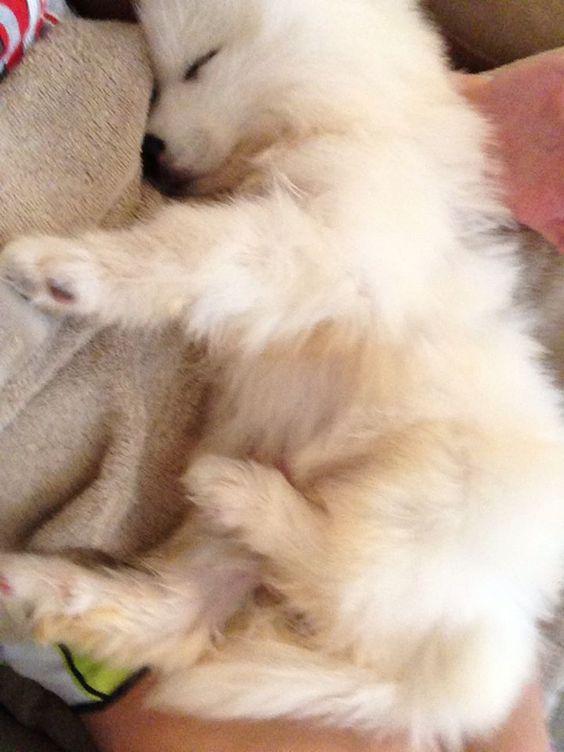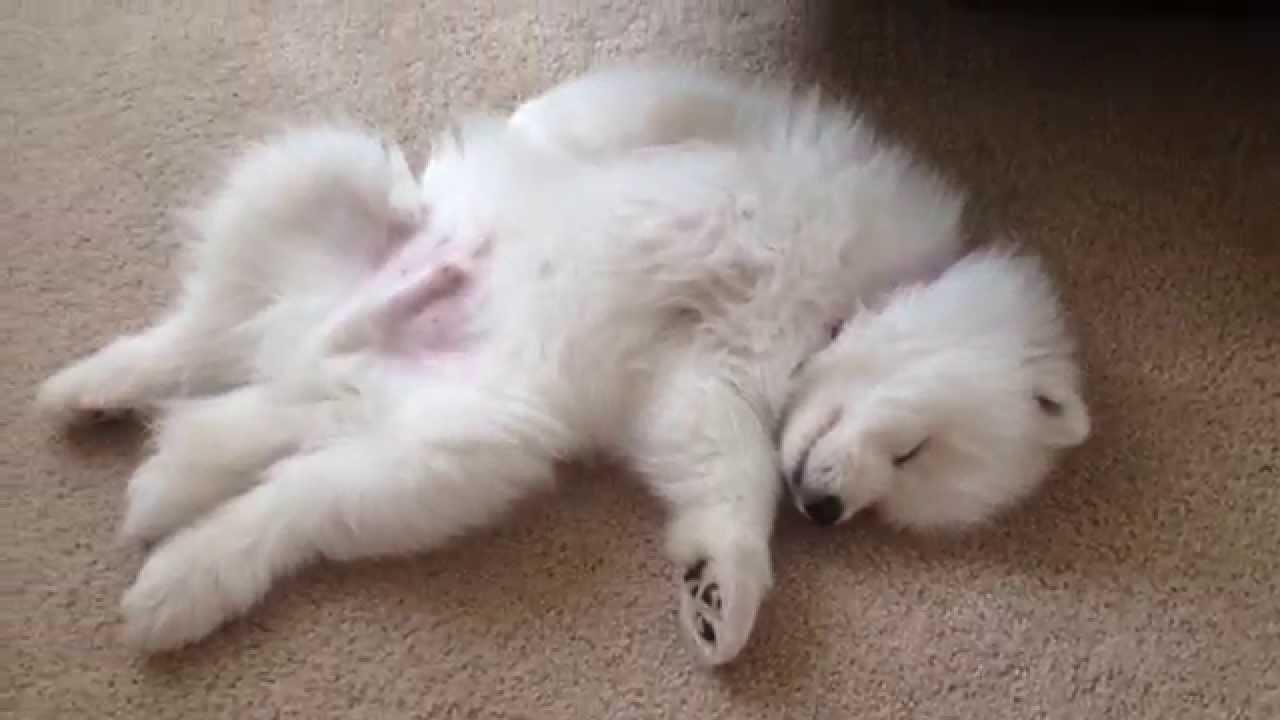The first image is the image on the left, the second image is the image on the right. Analyze the images presented: Is the assertion "The single white dog in the image on the right has its eyes open." valid? Answer yes or no. No. The first image is the image on the left, the second image is the image on the right. For the images displayed, is the sentence "One image features a reclining white dog with opened eyes." factually correct? Answer yes or no. No. 